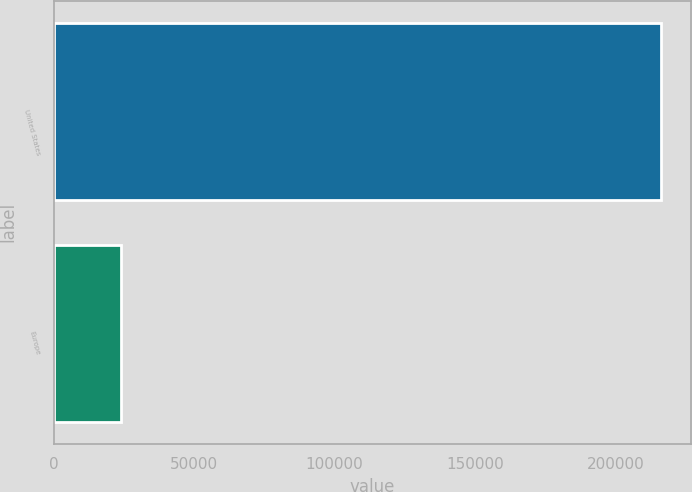Convert chart to OTSL. <chart><loc_0><loc_0><loc_500><loc_500><bar_chart><fcel>United States<fcel>Europe<nl><fcel>216138<fcel>23986<nl></chart> 